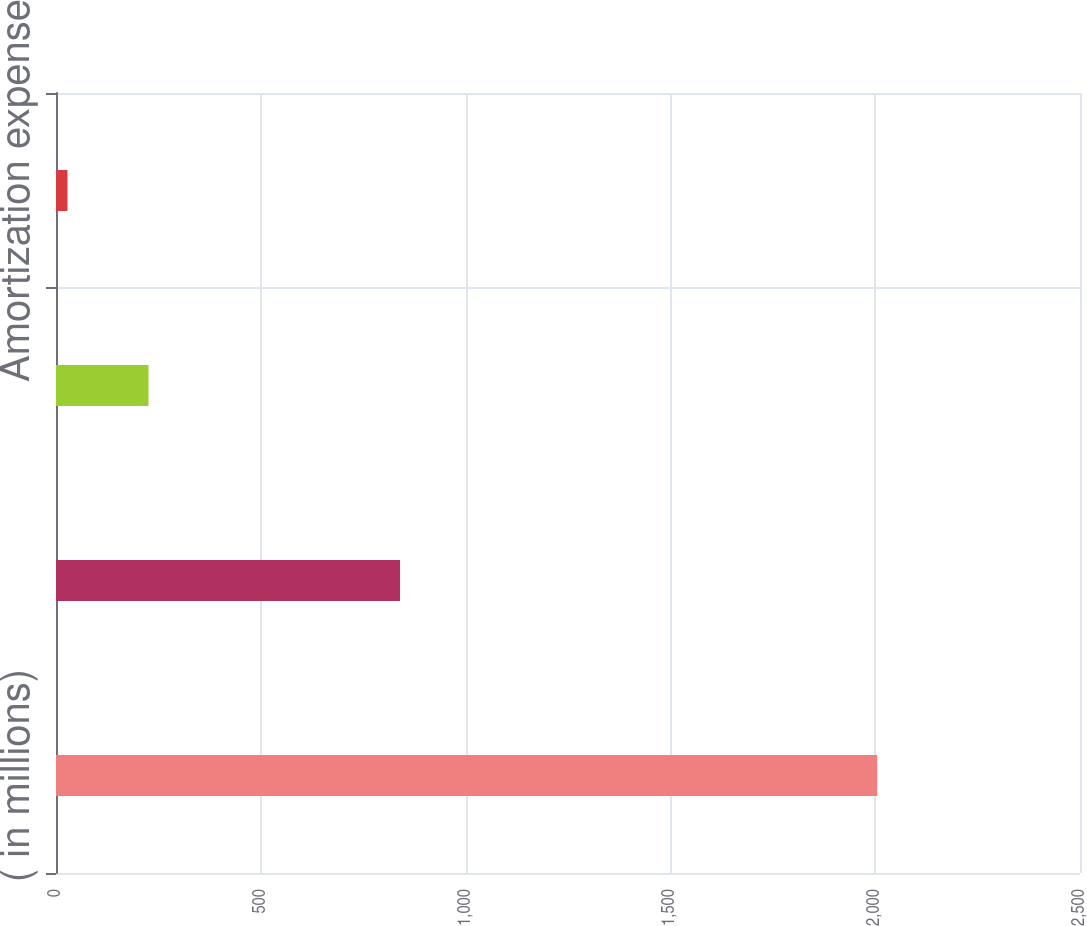<chart> <loc_0><loc_0><loc_500><loc_500><bar_chart><fcel>( in millions)<fcel>Cash from operations<fcel>Depreciation expense<fcel>Amortization expense<nl><fcel>2005<fcel>840<fcel>225.7<fcel>28<nl></chart> 